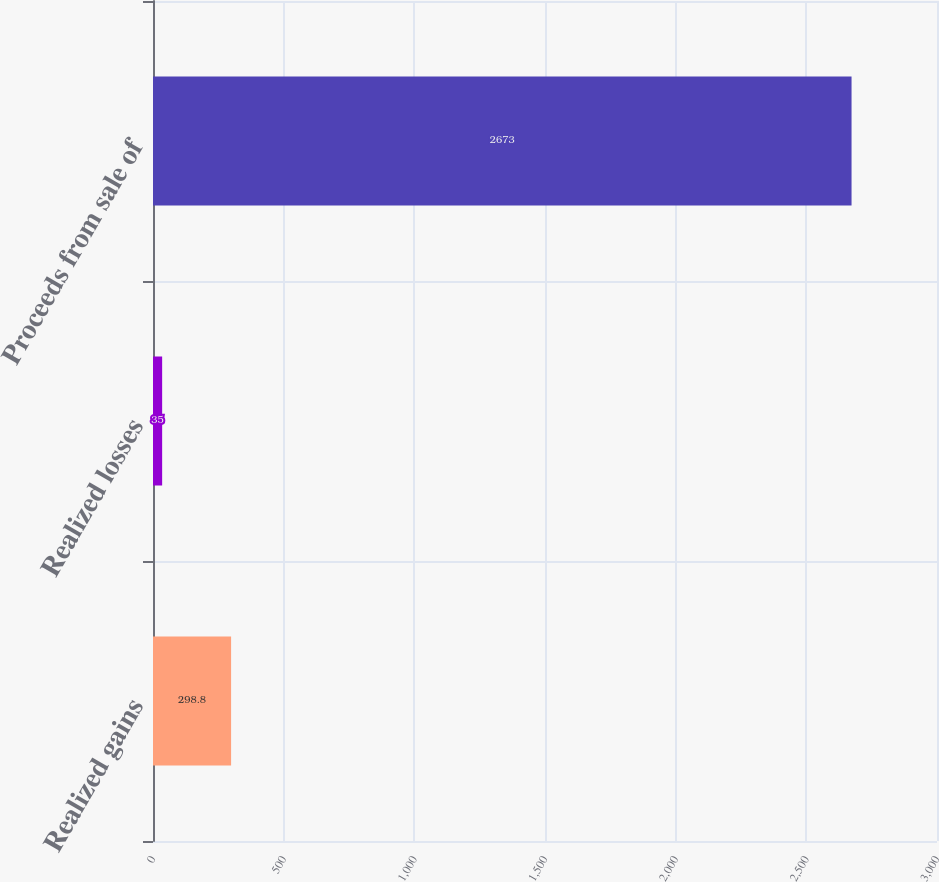Convert chart. <chart><loc_0><loc_0><loc_500><loc_500><bar_chart><fcel>Realized gains<fcel>Realized losses<fcel>Proceeds from sale of<nl><fcel>298.8<fcel>35<fcel>2673<nl></chart> 